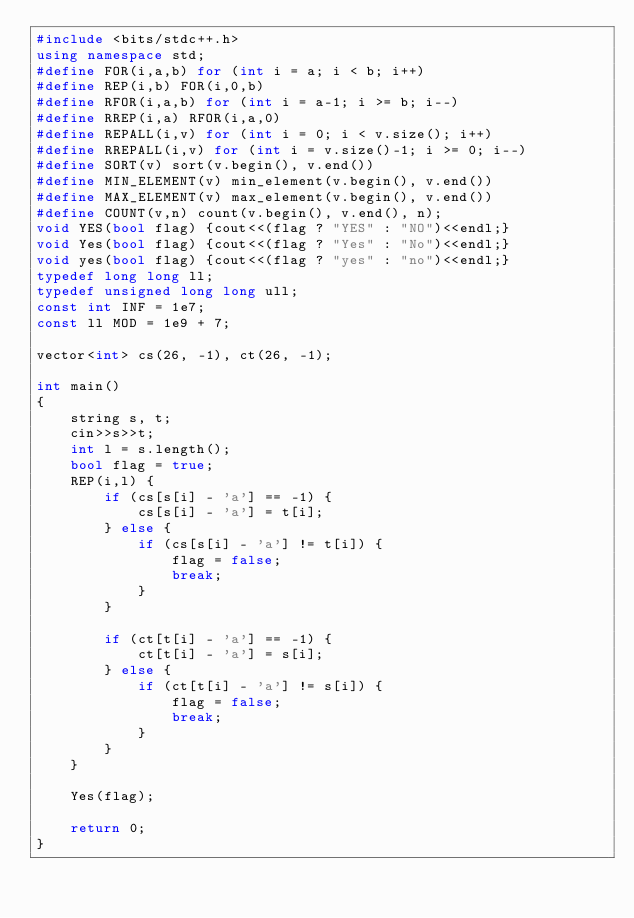Convert code to text. <code><loc_0><loc_0><loc_500><loc_500><_C++_>#include <bits/stdc++.h>
using namespace std;
#define FOR(i,a,b) for (int i = a; i < b; i++)
#define REP(i,b) FOR(i,0,b)
#define RFOR(i,a,b) for (int i = a-1; i >= b; i--)
#define RREP(i,a) RFOR(i,a,0)
#define REPALL(i,v) for (int i = 0; i < v.size(); i++)
#define RREPALL(i,v) for (int i = v.size()-1; i >= 0; i--)
#define SORT(v) sort(v.begin(), v.end())
#define MIN_ELEMENT(v) min_element(v.begin(), v.end())
#define MAX_ELEMENT(v) max_element(v.begin(), v.end())
#define COUNT(v,n) count(v.begin(), v.end(), n);
void YES(bool flag) {cout<<(flag ? "YES" : "NO")<<endl;}
void Yes(bool flag) {cout<<(flag ? "Yes" : "No")<<endl;}
void yes(bool flag) {cout<<(flag ? "yes" : "no")<<endl;}
typedef long long ll;
typedef unsigned long long ull;
const int INF = 1e7;
const ll MOD = 1e9 + 7;

vector<int> cs(26, -1), ct(26, -1);

int main()
{
    string s, t;
    cin>>s>>t;
    int l = s.length();
    bool flag = true;
    REP(i,l) {
        if (cs[s[i] - 'a'] == -1) {
            cs[s[i] - 'a'] = t[i];
        } else {
            if (cs[s[i] - 'a'] != t[i]) {
                flag = false;
                break;
            }
        }

        if (ct[t[i] - 'a'] == -1) {
            ct[t[i] - 'a'] = s[i];
        } else {
            if (ct[t[i] - 'a'] != s[i]) {
                flag = false;
                break;
            }
        }
    }

    Yes(flag);

    return 0;
}
</code> 